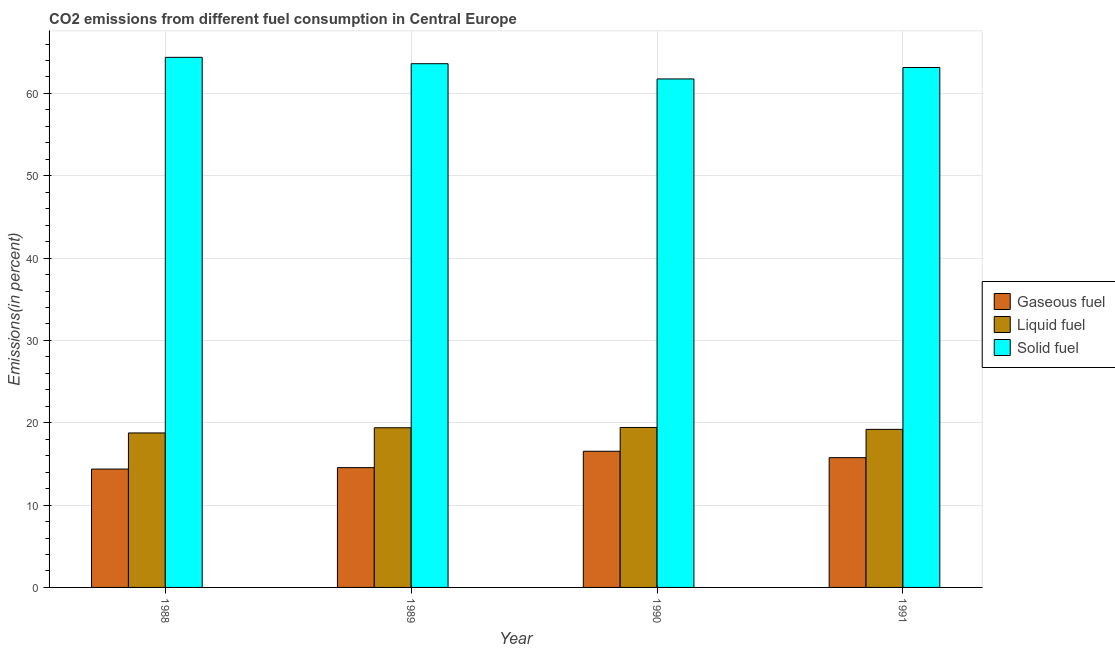How many different coloured bars are there?
Your answer should be very brief. 3. How many groups of bars are there?
Make the answer very short. 4. Are the number of bars per tick equal to the number of legend labels?
Make the answer very short. Yes. Are the number of bars on each tick of the X-axis equal?
Provide a short and direct response. Yes. How many bars are there on the 2nd tick from the right?
Your answer should be compact. 3. What is the percentage of liquid fuel emission in 1988?
Make the answer very short. 18.76. Across all years, what is the maximum percentage of gaseous fuel emission?
Provide a short and direct response. 16.54. Across all years, what is the minimum percentage of gaseous fuel emission?
Your answer should be very brief. 14.38. What is the total percentage of solid fuel emission in the graph?
Ensure brevity in your answer.  252.92. What is the difference between the percentage of solid fuel emission in 1988 and that in 1989?
Your answer should be very brief. 0.78. What is the difference between the percentage of gaseous fuel emission in 1989 and the percentage of solid fuel emission in 1990?
Provide a succinct answer. -1.99. What is the average percentage of solid fuel emission per year?
Make the answer very short. 63.23. In how many years, is the percentage of gaseous fuel emission greater than 36 %?
Ensure brevity in your answer.  0. What is the ratio of the percentage of solid fuel emission in 1988 to that in 1991?
Ensure brevity in your answer.  1.02. Is the percentage of liquid fuel emission in 1989 less than that in 1990?
Provide a short and direct response. Yes. Is the difference between the percentage of gaseous fuel emission in 1988 and 1990 greater than the difference between the percentage of solid fuel emission in 1988 and 1990?
Make the answer very short. No. What is the difference between the highest and the second highest percentage of solid fuel emission?
Ensure brevity in your answer.  0.78. What is the difference between the highest and the lowest percentage of gaseous fuel emission?
Your answer should be very brief. 2.16. What does the 3rd bar from the left in 1988 represents?
Provide a succinct answer. Solid fuel. What does the 3rd bar from the right in 1991 represents?
Your response must be concise. Gaseous fuel. Are all the bars in the graph horizontal?
Keep it short and to the point. No. How many years are there in the graph?
Provide a short and direct response. 4. Are the values on the major ticks of Y-axis written in scientific E-notation?
Keep it short and to the point. No. Does the graph contain any zero values?
Provide a succinct answer. No. Does the graph contain grids?
Ensure brevity in your answer.  Yes. Where does the legend appear in the graph?
Your answer should be compact. Center right. How many legend labels are there?
Offer a very short reply. 3. What is the title of the graph?
Ensure brevity in your answer.  CO2 emissions from different fuel consumption in Central Europe. Does "Spain" appear as one of the legend labels in the graph?
Ensure brevity in your answer.  No. What is the label or title of the Y-axis?
Ensure brevity in your answer.  Emissions(in percent). What is the Emissions(in percent) of Gaseous fuel in 1988?
Your answer should be compact. 14.38. What is the Emissions(in percent) of Liquid fuel in 1988?
Provide a succinct answer. 18.76. What is the Emissions(in percent) in Solid fuel in 1988?
Provide a succinct answer. 64.39. What is the Emissions(in percent) of Gaseous fuel in 1989?
Give a very brief answer. 14.55. What is the Emissions(in percent) in Liquid fuel in 1989?
Provide a succinct answer. 19.39. What is the Emissions(in percent) of Solid fuel in 1989?
Give a very brief answer. 63.61. What is the Emissions(in percent) in Gaseous fuel in 1990?
Offer a very short reply. 16.54. What is the Emissions(in percent) of Liquid fuel in 1990?
Provide a short and direct response. 19.43. What is the Emissions(in percent) of Solid fuel in 1990?
Keep it short and to the point. 61.76. What is the Emissions(in percent) in Gaseous fuel in 1991?
Keep it short and to the point. 15.76. What is the Emissions(in percent) in Liquid fuel in 1991?
Your answer should be very brief. 19.2. What is the Emissions(in percent) of Solid fuel in 1991?
Give a very brief answer. 63.15. Across all years, what is the maximum Emissions(in percent) of Gaseous fuel?
Offer a very short reply. 16.54. Across all years, what is the maximum Emissions(in percent) in Liquid fuel?
Your answer should be compact. 19.43. Across all years, what is the maximum Emissions(in percent) of Solid fuel?
Your response must be concise. 64.39. Across all years, what is the minimum Emissions(in percent) in Gaseous fuel?
Give a very brief answer. 14.38. Across all years, what is the minimum Emissions(in percent) in Liquid fuel?
Make the answer very short. 18.76. Across all years, what is the minimum Emissions(in percent) of Solid fuel?
Offer a very short reply. 61.76. What is the total Emissions(in percent) of Gaseous fuel in the graph?
Provide a short and direct response. 61.23. What is the total Emissions(in percent) in Liquid fuel in the graph?
Your answer should be very brief. 76.79. What is the total Emissions(in percent) of Solid fuel in the graph?
Provide a short and direct response. 252.92. What is the difference between the Emissions(in percent) of Gaseous fuel in 1988 and that in 1989?
Give a very brief answer. -0.17. What is the difference between the Emissions(in percent) of Liquid fuel in 1988 and that in 1989?
Offer a very short reply. -0.63. What is the difference between the Emissions(in percent) of Solid fuel in 1988 and that in 1989?
Provide a short and direct response. 0.78. What is the difference between the Emissions(in percent) of Gaseous fuel in 1988 and that in 1990?
Offer a terse response. -2.16. What is the difference between the Emissions(in percent) of Liquid fuel in 1988 and that in 1990?
Make the answer very short. -0.66. What is the difference between the Emissions(in percent) in Solid fuel in 1988 and that in 1990?
Your answer should be very brief. 2.62. What is the difference between the Emissions(in percent) of Gaseous fuel in 1988 and that in 1991?
Give a very brief answer. -1.39. What is the difference between the Emissions(in percent) of Liquid fuel in 1988 and that in 1991?
Provide a short and direct response. -0.43. What is the difference between the Emissions(in percent) of Solid fuel in 1988 and that in 1991?
Keep it short and to the point. 1.24. What is the difference between the Emissions(in percent) of Gaseous fuel in 1989 and that in 1990?
Provide a short and direct response. -1.99. What is the difference between the Emissions(in percent) of Liquid fuel in 1989 and that in 1990?
Your answer should be very brief. -0.03. What is the difference between the Emissions(in percent) in Solid fuel in 1989 and that in 1990?
Offer a very short reply. 1.85. What is the difference between the Emissions(in percent) in Gaseous fuel in 1989 and that in 1991?
Make the answer very short. -1.21. What is the difference between the Emissions(in percent) of Liquid fuel in 1989 and that in 1991?
Offer a very short reply. 0.2. What is the difference between the Emissions(in percent) of Solid fuel in 1989 and that in 1991?
Provide a succinct answer. 0.46. What is the difference between the Emissions(in percent) in Gaseous fuel in 1990 and that in 1991?
Offer a terse response. 0.78. What is the difference between the Emissions(in percent) of Liquid fuel in 1990 and that in 1991?
Your answer should be very brief. 0.23. What is the difference between the Emissions(in percent) in Solid fuel in 1990 and that in 1991?
Ensure brevity in your answer.  -1.39. What is the difference between the Emissions(in percent) in Gaseous fuel in 1988 and the Emissions(in percent) in Liquid fuel in 1989?
Keep it short and to the point. -5.02. What is the difference between the Emissions(in percent) of Gaseous fuel in 1988 and the Emissions(in percent) of Solid fuel in 1989?
Ensure brevity in your answer.  -49.24. What is the difference between the Emissions(in percent) of Liquid fuel in 1988 and the Emissions(in percent) of Solid fuel in 1989?
Make the answer very short. -44.85. What is the difference between the Emissions(in percent) in Gaseous fuel in 1988 and the Emissions(in percent) in Liquid fuel in 1990?
Your answer should be compact. -5.05. What is the difference between the Emissions(in percent) in Gaseous fuel in 1988 and the Emissions(in percent) in Solid fuel in 1990?
Give a very brief answer. -47.39. What is the difference between the Emissions(in percent) in Liquid fuel in 1988 and the Emissions(in percent) in Solid fuel in 1990?
Keep it short and to the point. -43. What is the difference between the Emissions(in percent) of Gaseous fuel in 1988 and the Emissions(in percent) of Liquid fuel in 1991?
Provide a succinct answer. -4.82. What is the difference between the Emissions(in percent) of Gaseous fuel in 1988 and the Emissions(in percent) of Solid fuel in 1991?
Offer a terse response. -48.78. What is the difference between the Emissions(in percent) of Liquid fuel in 1988 and the Emissions(in percent) of Solid fuel in 1991?
Make the answer very short. -44.39. What is the difference between the Emissions(in percent) of Gaseous fuel in 1989 and the Emissions(in percent) of Liquid fuel in 1990?
Make the answer very short. -4.88. What is the difference between the Emissions(in percent) in Gaseous fuel in 1989 and the Emissions(in percent) in Solid fuel in 1990?
Make the answer very short. -47.21. What is the difference between the Emissions(in percent) of Liquid fuel in 1989 and the Emissions(in percent) of Solid fuel in 1990?
Provide a succinct answer. -42.37. What is the difference between the Emissions(in percent) of Gaseous fuel in 1989 and the Emissions(in percent) of Liquid fuel in 1991?
Provide a short and direct response. -4.65. What is the difference between the Emissions(in percent) in Gaseous fuel in 1989 and the Emissions(in percent) in Solid fuel in 1991?
Provide a succinct answer. -48.6. What is the difference between the Emissions(in percent) in Liquid fuel in 1989 and the Emissions(in percent) in Solid fuel in 1991?
Your response must be concise. -43.76. What is the difference between the Emissions(in percent) in Gaseous fuel in 1990 and the Emissions(in percent) in Liquid fuel in 1991?
Make the answer very short. -2.66. What is the difference between the Emissions(in percent) in Gaseous fuel in 1990 and the Emissions(in percent) in Solid fuel in 1991?
Your response must be concise. -46.61. What is the difference between the Emissions(in percent) in Liquid fuel in 1990 and the Emissions(in percent) in Solid fuel in 1991?
Provide a succinct answer. -43.72. What is the average Emissions(in percent) in Gaseous fuel per year?
Ensure brevity in your answer.  15.31. What is the average Emissions(in percent) of Liquid fuel per year?
Your answer should be compact. 19.2. What is the average Emissions(in percent) in Solid fuel per year?
Your answer should be compact. 63.23. In the year 1988, what is the difference between the Emissions(in percent) of Gaseous fuel and Emissions(in percent) of Liquid fuel?
Ensure brevity in your answer.  -4.39. In the year 1988, what is the difference between the Emissions(in percent) in Gaseous fuel and Emissions(in percent) in Solid fuel?
Provide a succinct answer. -50.01. In the year 1988, what is the difference between the Emissions(in percent) of Liquid fuel and Emissions(in percent) of Solid fuel?
Make the answer very short. -45.62. In the year 1989, what is the difference between the Emissions(in percent) in Gaseous fuel and Emissions(in percent) in Liquid fuel?
Provide a succinct answer. -4.84. In the year 1989, what is the difference between the Emissions(in percent) of Gaseous fuel and Emissions(in percent) of Solid fuel?
Your answer should be compact. -49.06. In the year 1989, what is the difference between the Emissions(in percent) of Liquid fuel and Emissions(in percent) of Solid fuel?
Offer a very short reply. -44.22. In the year 1990, what is the difference between the Emissions(in percent) of Gaseous fuel and Emissions(in percent) of Liquid fuel?
Provide a short and direct response. -2.89. In the year 1990, what is the difference between the Emissions(in percent) in Gaseous fuel and Emissions(in percent) in Solid fuel?
Your answer should be very brief. -45.22. In the year 1990, what is the difference between the Emissions(in percent) in Liquid fuel and Emissions(in percent) in Solid fuel?
Make the answer very short. -42.34. In the year 1991, what is the difference between the Emissions(in percent) in Gaseous fuel and Emissions(in percent) in Liquid fuel?
Your response must be concise. -3.44. In the year 1991, what is the difference between the Emissions(in percent) of Gaseous fuel and Emissions(in percent) of Solid fuel?
Provide a succinct answer. -47.39. In the year 1991, what is the difference between the Emissions(in percent) in Liquid fuel and Emissions(in percent) in Solid fuel?
Your answer should be compact. -43.95. What is the ratio of the Emissions(in percent) of Gaseous fuel in 1988 to that in 1989?
Offer a terse response. 0.99. What is the ratio of the Emissions(in percent) in Liquid fuel in 1988 to that in 1989?
Your answer should be very brief. 0.97. What is the ratio of the Emissions(in percent) in Solid fuel in 1988 to that in 1989?
Provide a short and direct response. 1.01. What is the ratio of the Emissions(in percent) of Gaseous fuel in 1988 to that in 1990?
Provide a succinct answer. 0.87. What is the ratio of the Emissions(in percent) of Liquid fuel in 1988 to that in 1990?
Offer a terse response. 0.97. What is the ratio of the Emissions(in percent) of Solid fuel in 1988 to that in 1990?
Offer a very short reply. 1.04. What is the ratio of the Emissions(in percent) of Gaseous fuel in 1988 to that in 1991?
Give a very brief answer. 0.91. What is the ratio of the Emissions(in percent) of Liquid fuel in 1988 to that in 1991?
Your response must be concise. 0.98. What is the ratio of the Emissions(in percent) in Solid fuel in 1988 to that in 1991?
Give a very brief answer. 1.02. What is the ratio of the Emissions(in percent) of Gaseous fuel in 1989 to that in 1990?
Your answer should be very brief. 0.88. What is the ratio of the Emissions(in percent) of Solid fuel in 1989 to that in 1990?
Provide a succinct answer. 1.03. What is the ratio of the Emissions(in percent) in Gaseous fuel in 1989 to that in 1991?
Make the answer very short. 0.92. What is the ratio of the Emissions(in percent) in Liquid fuel in 1989 to that in 1991?
Offer a terse response. 1.01. What is the ratio of the Emissions(in percent) of Solid fuel in 1989 to that in 1991?
Your answer should be compact. 1.01. What is the ratio of the Emissions(in percent) of Gaseous fuel in 1990 to that in 1991?
Make the answer very short. 1.05. What is the ratio of the Emissions(in percent) of Liquid fuel in 1990 to that in 1991?
Your answer should be very brief. 1.01. What is the difference between the highest and the second highest Emissions(in percent) of Gaseous fuel?
Provide a succinct answer. 0.78. What is the difference between the highest and the second highest Emissions(in percent) of Liquid fuel?
Provide a succinct answer. 0.03. What is the difference between the highest and the second highest Emissions(in percent) of Solid fuel?
Give a very brief answer. 0.78. What is the difference between the highest and the lowest Emissions(in percent) in Gaseous fuel?
Offer a terse response. 2.16. What is the difference between the highest and the lowest Emissions(in percent) of Liquid fuel?
Ensure brevity in your answer.  0.66. What is the difference between the highest and the lowest Emissions(in percent) of Solid fuel?
Your answer should be very brief. 2.62. 